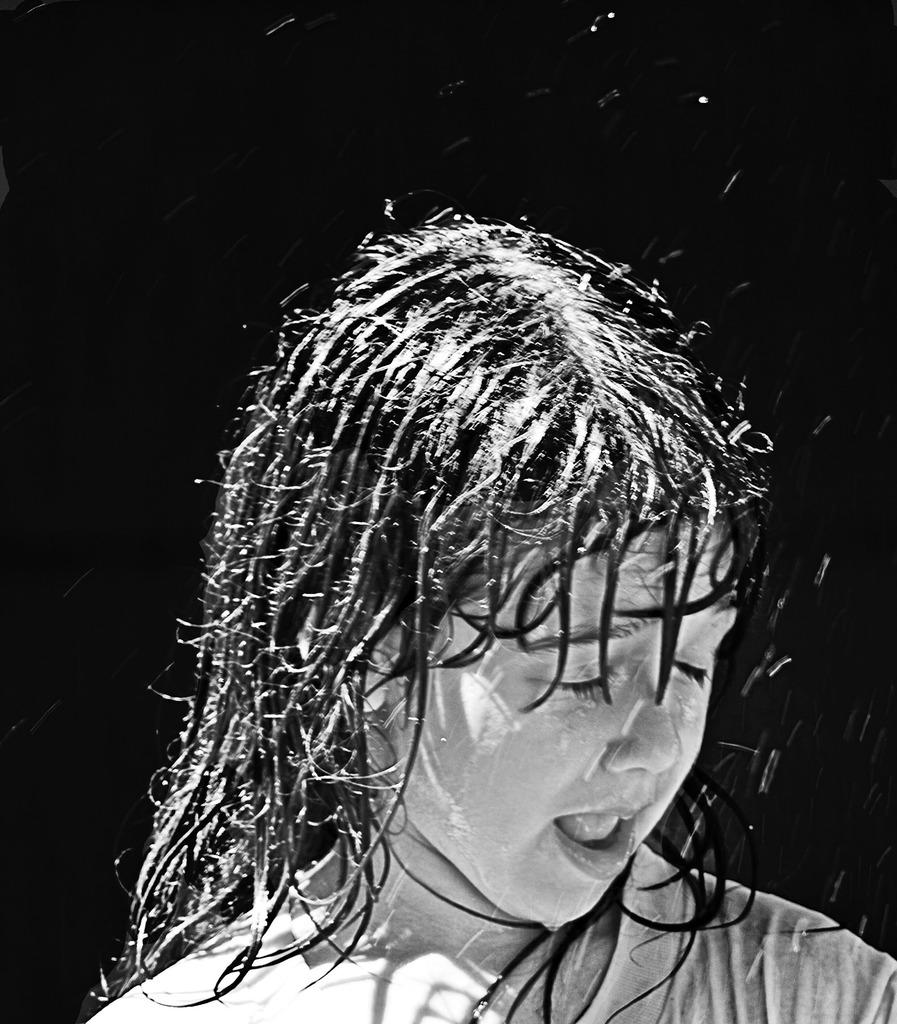What is the color scheme of the image? The image is black and white. What is the main subject of the image? There is a kid in the image. What is the kid doing in the image? The kid is taking a shower. What color is the background of the image? The background of the image is black. What type of arch can be seen in the image? There is no arch present in the image. What kind of trouble is the kid experiencing in the image? There is no indication of trouble in the image; the kid is simply taking a shower. 